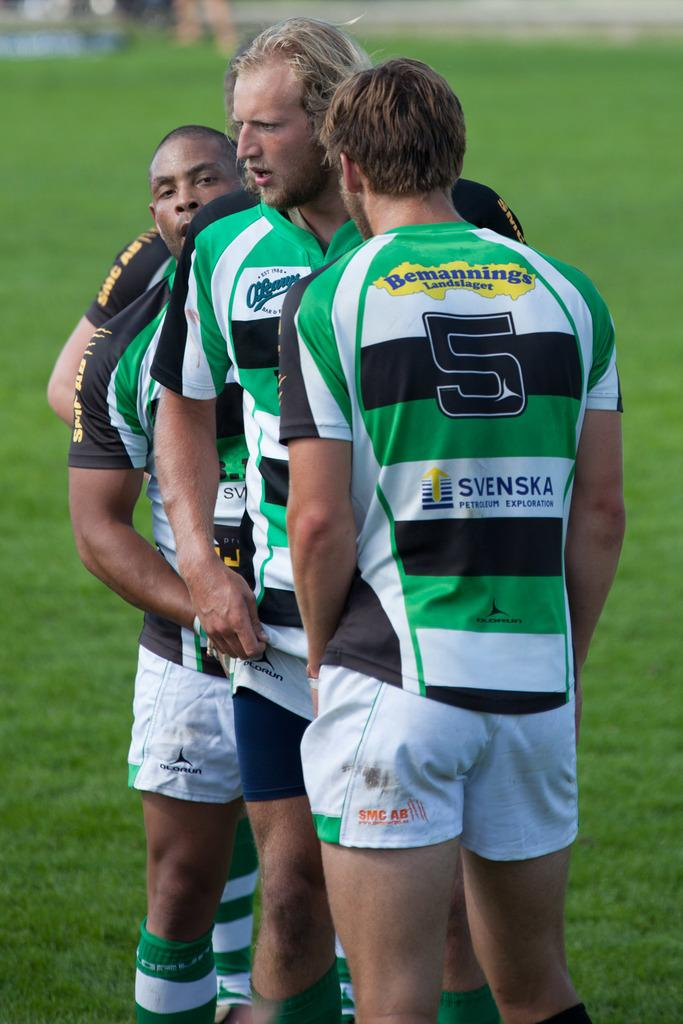<image>
Offer a succinct explanation of the picture presented. Number 5 stands on the field with some of his teammates. 